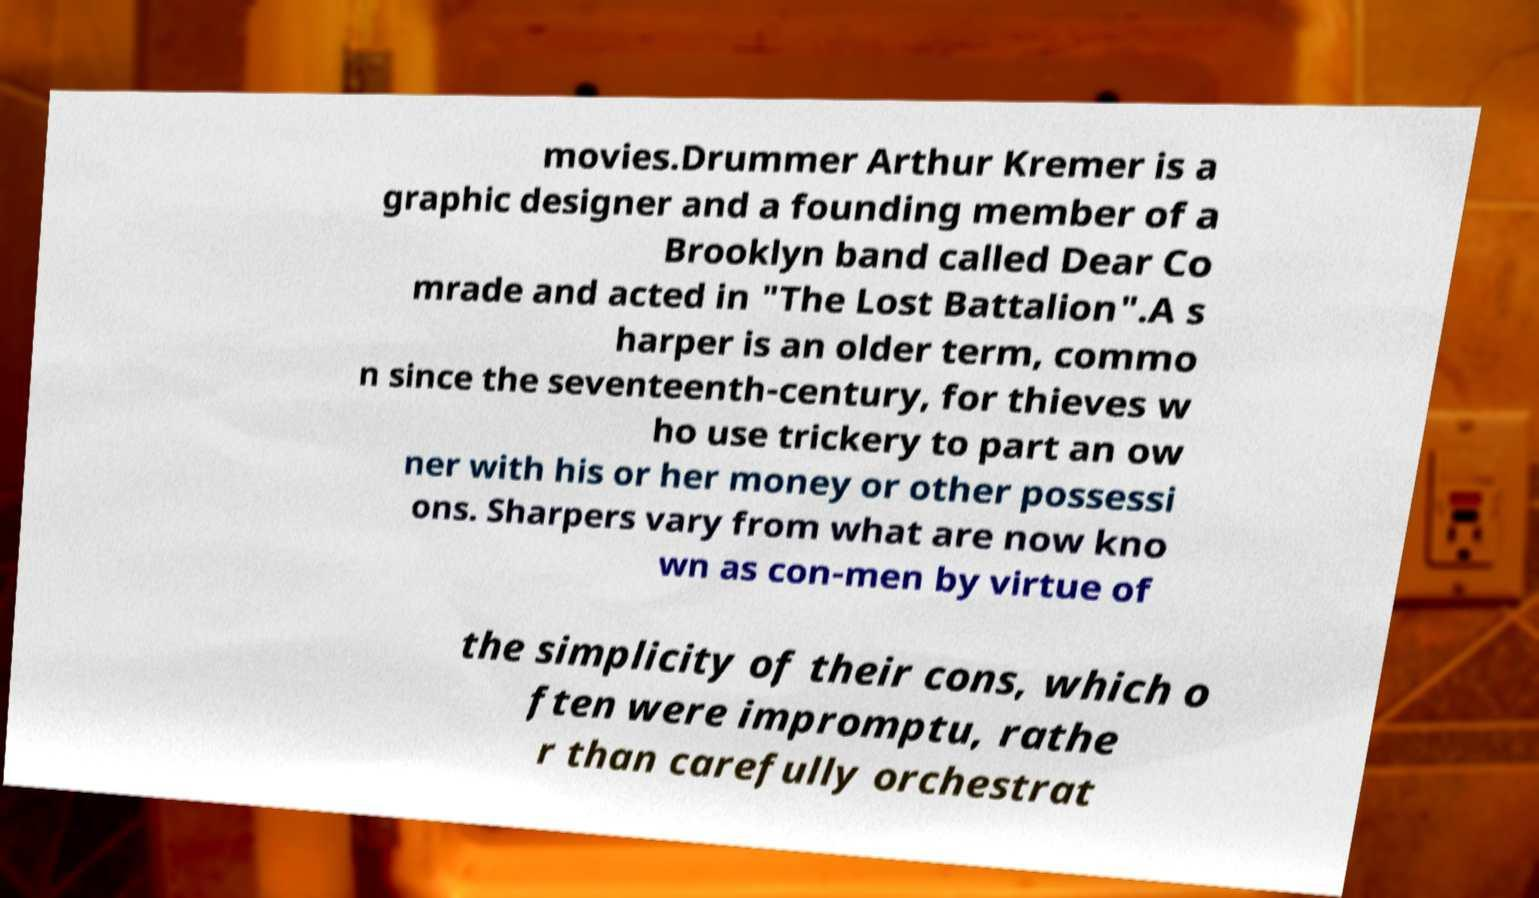What messages or text are displayed in this image? I need them in a readable, typed format. movies.Drummer Arthur Kremer is a graphic designer and a founding member of a Brooklyn band called Dear Co mrade and acted in "The Lost Battalion".A s harper is an older term, commo n since the seventeenth-century, for thieves w ho use trickery to part an ow ner with his or her money or other possessi ons. Sharpers vary from what are now kno wn as con-men by virtue of the simplicity of their cons, which o ften were impromptu, rathe r than carefully orchestrat 